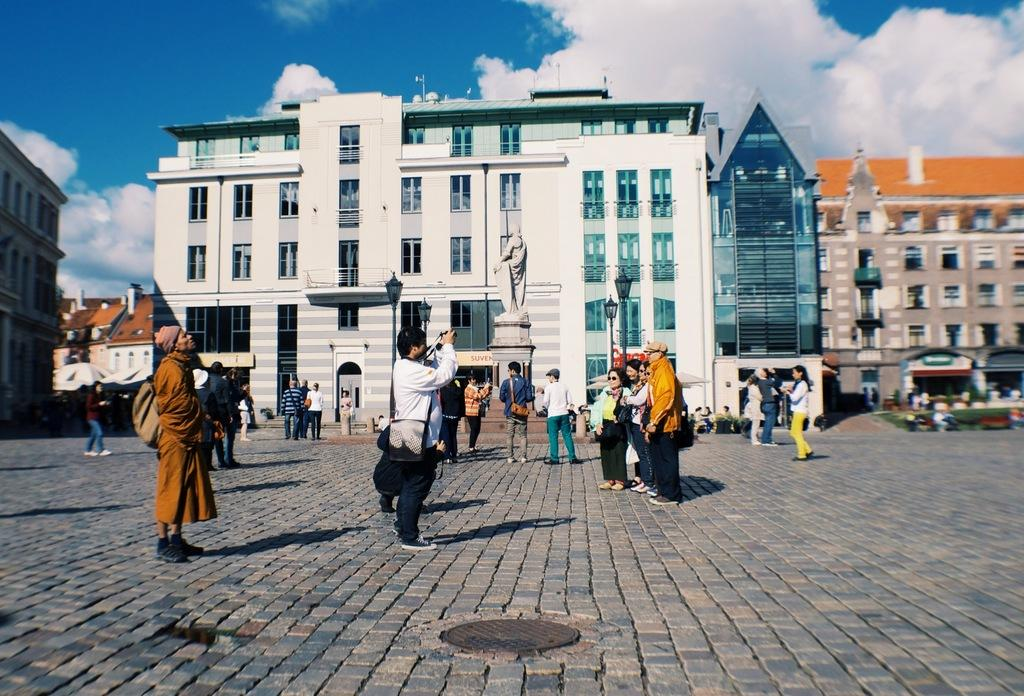How many people are in the group visible in the image? There is a group of people standing in the image, but the exact number cannot be determined from the provided facts. What is located behind the group of people? There is a statue behind the people in the image. What are the poles with lights used for in the image? The poles with lights are likely used for illumination in the image. What type of structures can be seen in the image? There are buildings visible in the image. What is visible in the background behind the buildings? The sky is visible behind the buildings in the image. What type of net is being used by the people in the image? There is no net visible in the image; it only shows a group of people, a statue, poles with lights, buildings, and the sky. 